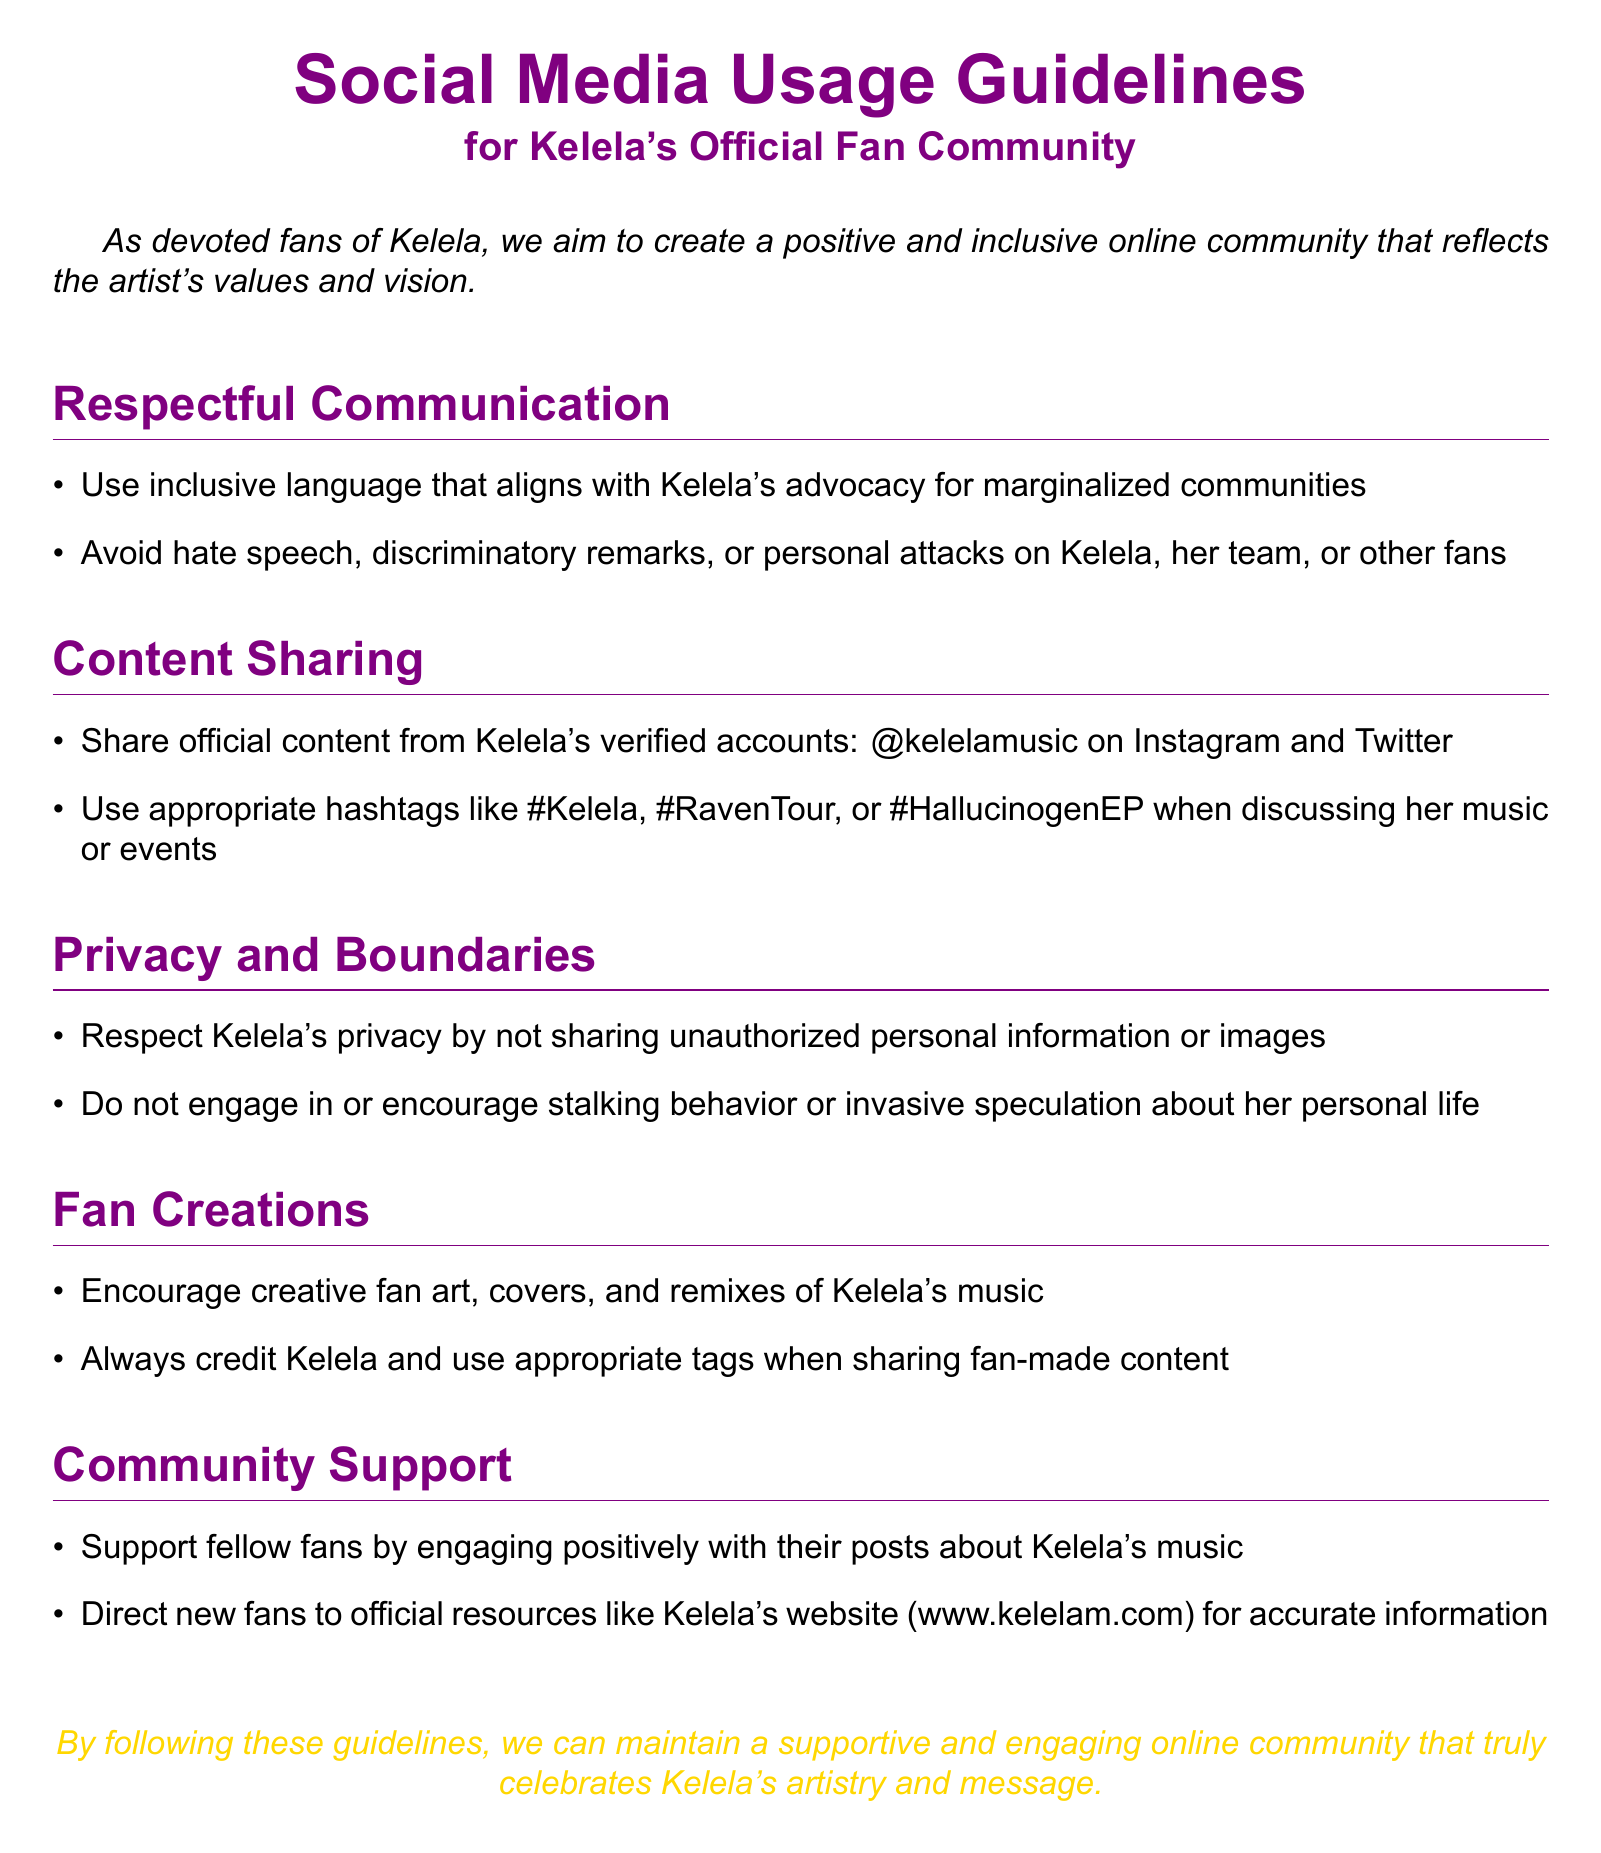What is the main purpose of the guidelines? The main purpose is to create a positive and inclusive online community that reflects Kelela's values and vision.
Answer: Positive and inclusive community Who should be credited when sharing fan creations? The guidelines specify that Kelela should be credited when sharing fan-made content.
Answer: Kelela Which social media accounts are official for Kelela? The document lists Kelela's verified accounts as @kelelamusic on Instagram and Twitter.
Answer: @kelelamusic What type of language should be used when communicating? The guidelines encourage the use of inclusive language that aligns with Kelela's advocacy.
Answer: Inclusive language What should fans avoid when discussing Kelela? Fans are advised to avoid hate speech, discriminatory remarks, or personal attacks.
Answer: Hate speech What is the website recommended for new fans? The document points fans to Kelela's official website for accurate information.
Answer: www.kelelam.com How should fans engage with fellow fans' posts? Fans should engage positively with their posts about Kelela's music.
Answer: Positively What type of behavior should not be encouraged? The guidelines clearly state that stalking behavior should not be engaged in or encouraged.
Answer: Stalking behavior 